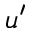Convert formula to latex. <formula><loc_0><loc_0><loc_500><loc_500>u ^ { \prime }</formula> 